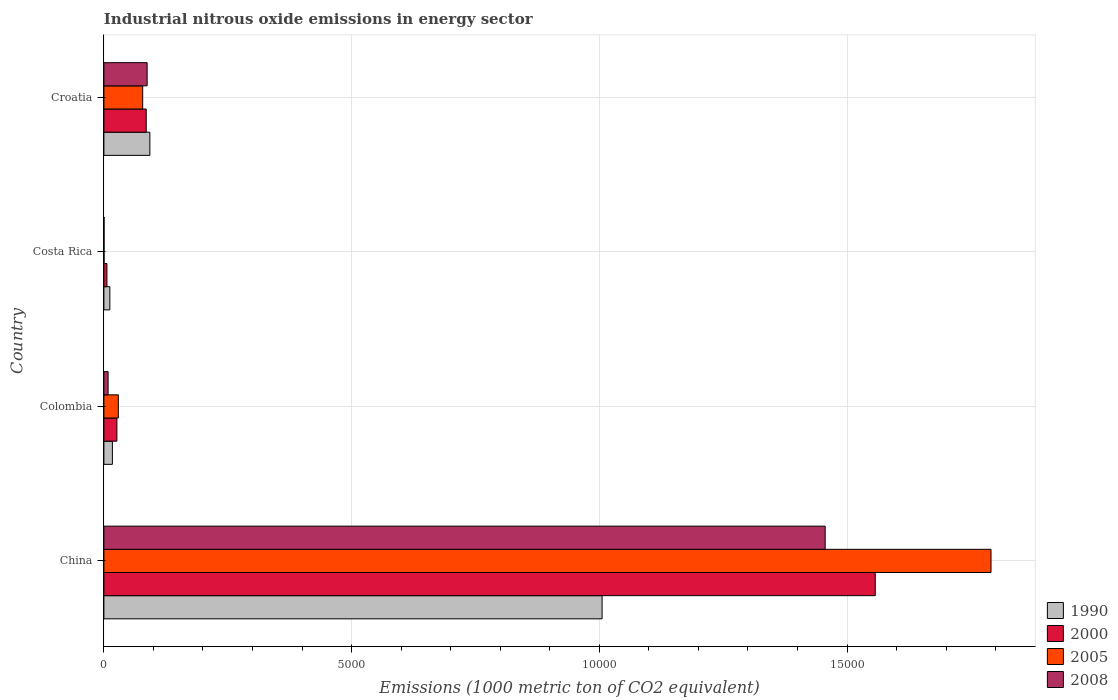How many different coloured bars are there?
Provide a short and direct response. 4. How many bars are there on the 4th tick from the bottom?
Your answer should be very brief. 4. What is the label of the 3rd group of bars from the top?
Your response must be concise. Colombia. What is the amount of industrial nitrous oxide emitted in 1990 in Costa Rica?
Provide a succinct answer. 120. Across all countries, what is the maximum amount of industrial nitrous oxide emitted in 2000?
Keep it short and to the point. 1.56e+04. Across all countries, what is the minimum amount of industrial nitrous oxide emitted in 2008?
Your response must be concise. 3.1. What is the total amount of industrial nitrous oxide emitted in 2008 in the graph?
Make the answer very short. 1.55e+04. What is the difference between the amount of industrial nitrous oxide emitted in 2005 in China and that in Colombia?
Offer a terse response. 1.76e+04. What is the difference between the amount of industrial nitrous oxide emitted in 2005 in Colombia and the amount of industrial nitrous oxide emitted in 1990 in China?
Provide a short and direct response. -9764.8. What is the average amount of industrial nitrous oxide emitted in 1990 per country?
Ensure brevity in your answer.  2818.85. What is the difference between the amount of industrial nitrous oxide emitted in 2008 and amount of industrial nitrous oxide emitted in 2005 in China?
Your response must be concise. -3347.5. What is the ratio of the amount of industrial nitrous oxide emitted in 1990 in China to that in Croatia?
Ensure brevity in your answer.  10.84. Is the amount of industrial nitrous oxide emitted in 2005 in Colombia less than that in Croatia?
Keep it short and to the point. Yes. What is the difference between the highest and the second highest amount of industrial nitrous oxide emitted in 1990?
Offer a terse response. 9128.4. What is the difference between the highest and the lowest amount of industrial nitrous oxide emitted in 2000?
Keep it short and to the point. 1.55e+04. In how many countries, is the amount of industrial nitrous oxide emitted in 1990 greater than the average amount of industrial nitrous oxide emitted in 1990 taken over all countries?
Your answer should be very brief. 1. Is the sum of the amount of industrial nitrous oxide emitted in 2005 in Colombia and Croatia greater than the maximum amount of industrial nitrous oxide emitted in 2000 across all countries?
Your answer should be compact. No. Is it the case that in every country, the sum of the amount of industrial nitrous oxide emitted in 2005 and amount of industrial nitrous oxide emitted in 1990 is greater than the sum of amount of industrial nitrous oxide emitted in 2000 and amount of industrial nitrous oxide emitted in 2008?
Your answer should be very brief. No. What does the 4th bar from the top in Colombia represents?
Your answer should be compact. 1990. What does the 4th bar from the bottom in Croatia represents?
Your response must be concise. 2008. How many bars are there?
Keep it short and to the point. 16. Are all the bars in the graph horizontal?
Make the answer very short. Yes. How many countries are there in the graph?
Your response must be concise. 4. What is the difference between two consecutive major ticks on the X-axis?
Ensure brevity in your answer.  5000. Are the values on the major ticks of X-axis written in scientific E-notation?
Provide a succinct answer. No. Does the graph contain grids?
Make the answer very short. Yes. Where does the legend appear in the graph?
Keep it short and to the point. Bottom right. How many legend labels are there?
Keep it short and to the point. 4. How are the legend labels stacked?
Offer a terse response. Vertical. What is the title of the graph?
Your answer should be very brief. Industrial nitrous oxide emissions in energy sector. Does "1970" appear as one of the legend labels in the graph?
Provide a short and direct response. No. What is the label or title of the X-axis?
Your answer should be very brief. Emissions (1000 metric ton of CO2 equivalent). What is the label or title of the Y-axis?
Keep it short and to the point. Country. What is the Emissions (1000 metric ton of CO2 equivalent) in 1990 in China?
Your answer should be compact. 1.01e+04. What is the Emissions (1000 metric ton of CO2 equivalent) in 2000 in China?
Provide a short and direct response. 1.56e+04. What is the Emissions (1000 metric ton of CO2 equivalent) of 2005 in China?
Make the answer very short. 1.79e+04. What is the Emissions (1000 metric ton of CO2 equivalent) of 2008 in China?
Provide a short and direct response. 1.46e+04. What is the Emissions (1000 metric ton of CO2 equivalent) in 1990 in Colombia?
Provide a short and direct response. 171.6. What is the Emissions (1000 metric ton of CO2 equivalent) in 2000 in Colombia?
Provide a short and direct response. 262.3. What is the Emissions (1000 metric ton of CO2 equivalent) of 2005 in Colombia?
Your response must be concise. 291.3. What is the Emissions (1000 metric ton of CO2 equivalent) in 2008 in Colombia?
Your answer should be very brief. 84.7. What is the Emissions (1000 metric ton of CO2 equivalent) in 1990 in Costa Rica?
Provide a succinct answer. 120. What is the Emissions (1000 metric ton of CO2 equivalent) of 2000 in Costa Rica?
Your response must be concise. 61.4. What is the Emissions (1000 metric ton of CO2 equivalent) of 2008 in Costa Rica?
Offer a terse response. 3.1. What is the Emissions (1000 metric ton of CO2 equivalent) in 1990 in Croatia?
Your response must be concise. 927.7. What is the Emissions (1000 metric ton of CO2 equivalent) of 2000 in Croatia?
Your answer should be very brief. 854.3. What is the Emissions (1000 metric ton of CO2 equivalent) in 2005 in Croatia?
Your response must be concise. 783.2. What is the Emissions (1000 metric ton of CO2 equivalent) of 2008 in Croatia?
Keep it short and to the point. 873. Across all countries, what is the maximum Emissions (1000 metric ton of CO2 equivalent) of 1990?
Ensure brevity in your answer.  1.01e+04. Across all countries, what is the maximum Emissions (1000 metric ton of CO2 equivalent) in 2000?
Your answer should be compact. 1.56e+04. Across all countries, what is the maximum Emissions (1000 metric ton of CO2 equivalent) of 2005?
Offer a very short reply. 1.79e+04. Across all countries, what is the maximum Emissions (1000 metric ton of CO2 equivalent) of 2008?
Offer a very short reply. 1.46e+04. Across all countries, what is the minimum Emissions (1000 metric ton of CO2 equivalent) of 1990?
Offer a very short reply. 120. Across all countries, what is the minimum Emissions (1000 metric ton of CO2 equivalent) in 2000?
Your answer should be very brief. 61.4. What is the total Emissions (1000 metric ton of CO2 equivalent) in 1990 in the graph?
Provide a short and direct response. 1.13e+04. What is the total Emissions (1000 metric ton of CO2 equivalent) in 2000 in the graph?
Keep it short and to the point. 1.67e+04. What is the total Emissions (1000 metric ton of CO2 equivalent) of 2005 in the graph?
Provide a short and direct response. 1.90e+04. What is the total Emissions (1000 metric ton of CO2 equivalent) of 2008 in the graph?
Offer a terse response. 1.55e+04. What is the difference between the Emissions (1000 metric ton of CO2 equivalent) in 1990 in China and that in Colombia?
Your answer should be very brief. 9884.5. What is the difference between the Emissions (1000 metric ton of CO2 equivalent) of 2000 in China and that in Colombia?
Your answer should be very brief. 1.53e+04. What is the difference between the Emissions (1000 metric ton of CO2 equivalent) in 2005 in China and that in Colombia?
Your answer should be compact. 1.76e+04. What is the difference between the Emissions (1000 metric ton of CO2 equivalent) of 2008 in China and that in Colombia?
Provide a succinct answer. 1.45e+04. What is the difference between the Emissions (1000 metric ton of CO2 equivalent) in 1990 in China and that in Costa Rica?
Provide a short and direct response. 9936.1. What is the difference between the Emissions (1000 metric ton of CO2 equivalent) of 2000 in China and that in Costa Rica?
Make the answer very short. 1.55e+04. What is the difference between the Emissions (1000 metric ton of CO2 equivalent) of 2005 in China and that in Costa Rica?
Your response must be concise. 1.79e+04. What is the difference between the Emissions (1000 metric ton of CO2 equivalent) in 2008 in China and that in Costa Rica?
Keep it short and to the point. 1.46e+04. What is the difference between the Emissions (1000 metric ton of CO2 equivalent) in 1990 in China and that in Croatia?
Your answer should be compact. 9128.4. What is the difference between the Emissions (1000 metric ton of CO2 equivalent) in 2000 in China and that in Croatia?
Your answer should be very brief. 1.47e+04. What is the difference between the Emissions (1000 metric ton of CO2 equivalent) in 2005 in China and that in Croatia?
Provide a succinct answer. 1.71e+04. What is the difference between the Emissions (1000 metric ton of CO2 equivalent) in 2008 in China and that in Croatia?
Your response must be concise. 1.37e+04. What is the difference between the Emissions (1000 metric ton of CO2 equivalent) in 1990 in Colombia and that in Costa Rica?
Provide a succinct answer. 51.6. What is the difference between the Emissions (1000 metric ton of CO2 equivalent) of 2000 in Colombia and that in Costa Rica?
Your response must be concise. 200.9. What is the difference between the Emissions (1000 metric ton of CO2 equivalent) in 2005 in Colombia and that in Costa Rica?
Your answer should be compact. 288.2. What is the difference between the Emissions (1000 metric ton of CO2 equivalent) in 2008 in Colombia and that in Costa Rica?
Keep it short and to the point. 81.6. What is the difference between the Emissions (1000 metric ton of CO2 equivalent) in 1990 in Colombia and that in Croatia?
Ensure brevity in your answer.  -756.1. What is the difference between the Emissions (1000 metric ton of CO2 equivalent) of 2000 in Colombia and that in Croatia?
Your answer should be very brief. -592. What is the difference between the Emissions (1000 metric ton of CO2 equivalent) in 2005 in Colombia and that in Croatia?
Your answer should be very brief. -491.9. What is the difference between the Emissions (1000 metric ton of CO2 equivalent) in 2008 in Colombia and that in Croatia?
Ensure brevity in your answer.  -788.3. What is the difference between the Emissions (1000 metric ton of CO2 equivalent) of 1990 in Costa Rica and that in Croatia?
Your answer should be compact. -807.7. What is the difference between the Emissions (1000 metric ton of CO2 equivalent) in 2000 in Costa Rica and that in Croatia?
Your response must be concise. -792.9. What is the difference between the Emissions (1000 metric ton of CO2 equivalent) in 2005 in Costa Rica and that in Croatia?
Ensure brevity in your answer.  -780.1. What is the difference between the Emissions (1000 metric ton of CO2 equivalent) in 2008 in Costa Rica and that in Croatia?
Your answer should be very brief. -869.9. What is the difference between the Emissions (1000 metric ton of CO2 equivalent) in 1990 in China and the Emissions (1000 metric ton of CO2 equivalent) in 2000 in Colombia?
Give a very brief answer. 9793.8. What is the difference between the Emissions (1000 metric ton of CO2 equivalent) of 1990 in China and the Emissions (1000 metric ton of CO2 equivalent) of 2005 in Colombia?
Provide a short and direct response. 9764.8. What is the difference between the Emissions (1000 metric ton of CO2 equivalent) in 1990 in China and the Emissions (1000 metric ton of CO2 equivalent) in 2008 in Colombia?
Provide a succinct answer. 9971.4. What is the difference between the Emissions (1000 metric ton of CO2 equivalent) of 2000 in China and the Emissions (1000 metric ton of CO2 equivalent) of 2005 in Colombia?
Offer a very short reply. 1.53e+04. What is the difference between the Emissions (1000 metric ton of CO2 equivalent) of 2000 in China and the Emissions (1000 metric ton of CO2 equivalent) of 2008 in Colombia?
Provide a short and direct response. 1.55e+04. What is the difference between the Emissions (1000 metric ton of CO2 equivalent) in 2005 in China and the Emissions (1000 metric ton of CO2 equivalent) in 2008 in Colombia?
Provide a succinct answer. 1.78e+04. What is the difference between the Emissions (1000 metric ton of CO2 equivalent) of 1990 in China and the Emissions (1000 metric ton of CO2 equivalent) of 2000 in Costa Rica?
Give a very brief answer. 9994.7. What is the difference between the Emissions (1000 metric ton of CO2 equivalent) in 1990 in China and the Emissions (1000 metric ton of CO2 equivalent) in 2005 in Costa Rica?
Make the answer very short. 1.01e+04. What is the difference between the Emissions (1000 metric ton of CO2 equivalent) of 1990 in China and the Emissions (1000 metric ton of CO2 equivalent) of 2008 in Costa Rica?
Ensure brevity in your answer.  1.01e+04. What is the difference between the Emissions (1000 metric ton of CO2 equivalent) of 2000 in China and the Emissions (1000 metric ton of CO2 equivalent) of 2005 in Costa Rica?
Your answer should be compact. 1.56e+04. What is the difference between the Emissions (1000 metric ton of CO2 equivalent) in 2000 in China and the Emissions (1000 metric ton of CO2 equivalent) in 2008 in Costa Rica?
Offer a terse response. 1.56e+04. What is the difference between the Emissions (1000 metric ton of CO2 equivalent) in 2005 in China and the Emissions (1000 metric ton of CO2 equivalent) in 2008 in Costa Rica?
Offer a terse response. 1.79e+04. What is the difference between the Emissions (1000 metric ton of CO2 equivalent) in 1990 in China and the Emissions (1000 metric ton of CO2 equivalent) in 2000 in Croatia?
Provide a short and direct response. 9201.8. What is the difference between the Emissions (1000 metric ton of CO2 equivalent) of 1990 in China and the Emissions (1000 metric ton of CO2 equivalent) of 2005 in Croatia?
Offer a terse response. 9272.9. What is the difference between the Emissions (1000 metric ton of CO2 equivalent) of 1990 in China and the Emissions (1000 metric ton of CO2 equivalent) of 2008 in Croatia?
Provide a short and direct response. 9183.1. What is the difference between the Emissions (1000 metric ton of CO2 equivalent) in 2000 in China and the Emissions (1000 metric ton of CO2 equivalent) in 2005 in Croatia?
Give a very brief answer. 1.48e+04. What is the difference between the Emissions (1000 metric ton of CO2 equivalent) of 2000 in China and the Emissions (1000 metric ton of CO2 equivalent) of 2008 in Croatia?
Make the answer very short. 1.47e+04. What is the difference between the Emissions (1000 metric ton of CO2 equivalent) in 2005 in China and the Emissions (1000 metric ton of CO2 equivalent) in 2008 in Croatia?
Your answer should be very brief. 1.70e+04. What is the difference between the Emissions (1000 metric ton of CO2 equivalent) of 1990 in Colombia and the Emissions (1000 metric ton of CO2 equivalent) of 2000 in Costa Rica?
Offer a very short reply. 110.2. What is the difference between the Emissions (1000 metric ton of CO2 equivalent) of 1990 in Colombia and the Emissions (1000 metric ton of CO2 equivalent) of 2005 in Costa Rica?
Offer a terse response. 168.5. What is the difference between the Emissions (1000 metric ton of CO2 equivalent) of 1990 in Colombia and the Emissions (1000 metric ton of CO2 equivalent) of 2008 in Costa Rica?
Offer a very short reply. 168.5. What is the difference between the Emissions (1000 metric ton of CO2 equivalent) of 2000 in Colombia and the Emissions (1000 metric ton of CO2 equivalent) of 2005 in Costa Rica?
Provide a short and direct response. 259.2. What is the difference between the Emissions (1000 metric ton of CO2 equivalent) of 2000 in Colombia and the Emissions (1000 metric ton of CO2 equivalent) of 2008 in Costa Rica?
Make the answer very short. 259.2. What is the difference between the Emissions (1000 metric ton of CO2 equivalent) of 2005 in Colombia and the Emissions (1000 metric ton of CO2 equivalent) of 2008 in Costa Rica?
Provide a succinct answer. 288.2. What is the difference between the Emissions (1000 metric ton of CO2 equivalent) of 1990 in Colombia and the Emissions (1000 metric ton of CO2 equivalent) of 2000 in Croatia?
Provide a succinct answer. -682.7. What is the difference between the Emissions (1000 metric ton of CO2 equivalent) of 1990 in Colombia and the Emissions (1000 metric ton of CO2 equivalent) of 2005 in Croatia?
Ensure brevity in your answer.  -611.6. What is the difference between the Emissions (1000 metric ton of CO2 equivalent) in 1990 in Colombia and the Emissions (1000 metric ton of CO2 equivalent) in 2008 in Croatia?
Offer a terse response. -701.4. What is the difference between the Emissions (1000 metric ton of CO2 equivalent) of 2000 in Colombia and the Emissions (1000 metric ton of CO2 equivalent) of 2005 in Croatia?
Give a very brief answer. -520.9. What is the difference between the Emissions (1000 metric ton of CO2 equivalent) of 2000 in Colombia and the Emissions (1000 metric ton of CO2 equivalent) of 2008 in Croatia?
Provide a short and direct response. -610.7. What is the difference between the Emissions (1000 metric ton of CO2 equivalent) of 2005 in Colombia and the Emissions (1000 metric ton of CO2 equivalent) of 2008 in Croatia?
Make the answer very short. -581.7. What is the difference between the Emissions (1000 metric ton of CO2 equivalent) of 1990 in Costa Rica and the Emissions (1000 metric ton of CO2 equivalent) of 2000 in Croatia?
Give a very brief answer. -734.3. What is the difference between the Emissions (1000 metric ton of CO2 equivalent) in 1990 in Costa Rica and the Emissions (1000 metric ton of CO2 equivalent) in 2005 in Croatia?
Your answer should be compact. -663.2. What is the difference between the Emissions (1000 metric ton of CO2 equivalent) of 1990 in Costa Rica and the Emissions (1000 metric ton of CO2 equivalent) of 2008 in Croatia?
Your answer should be very brief. -753. What is the difference between the Emissions (1000 metric ton of CO2 equivalent) of 2000 in Costa Rica and the Emissions (1000 metric ton of CO2 equivalent) of 2005 in Croatia?
Provide a succinct answer. -721.8. What is the difference between the Emissions (1000 metric ton of CO2 equivalent) in 2000 in Costa Rica and the Emissions (1000 metric ton of CO2 equivalent) in 2008 in Croatia?
Provide a succinct answer. -811.6. What is the difference between the Emissions (1000 metric ton of CO2 equivalent) in 2005 in Costa Rica and the Emissions (1000 metric ton of CO2 equivalent) in 2008 in Croatia?
Offer a very short reply. -869.9. What is the average Emissions (1000 metric ton of CO2 equivalent) in 1990 per country?
Ensure brevity in your answer.  2818.85. What is the average Emissions (1000 metric ton of CO2 equivalent) in 2000 per country?
Provide a short and direct response. 4186.93. What is the average Emissions (1000 metric ton of CO2 equivalent) in 2005 per country?
Give a very brief answer. 4746. What is the average Emissions (1000 metric ton of CO2 equivalent) of 2008 per country?
Ensure brevity in your answer.  3879.93. What is the difference between the Emissions (1000 metric ton of CO2 equivalent) of 1990 and Emissions (1000 metric ton of CO2 equivalent) of 2000 in China?
Keep it short and to the point. -5513.6. What is the difference between the Emissions (1000 metric ton of CO2 equivalent) in 1990 and Emissions (1000 metric ton of CO2 equivalent) in 2005 in China?
Your answer should be compact. -7850.3. What is the difference between the Emissions (1000 metric ton of CO2 equivalent) of 1990 and Emissions (1000 metric ton of CO2 equivalent) of 2008 in China?
Your answer should be compact. -4502.8. What is the difference between the Emissions (1000 metric ton of CO2 equivalent) in 2000 and Emissions (1000 metric ton of CO2 equivalent) in 2005 in China?
Your response must be concise. -2336.7. What is the difference between the Emissions (1000 metric ton of CO2 equivalent) in 2000 and Emissions (1000 metric ton of CO2 equivalent) in 2008 in China?
Provide a short and direct response. 1010.8. What is the difference between the Emissions (1000 metric ton of CO2 equivalent) in 2005 and Emissions (1000 metric ton of CO2 equivalent) in 2008 in China?
Offer a very short reply. 3347.5. What is the difference between the Emissions (1000 metric ton of CO2 equivalent) in 1990 and Emissions (1000 metric ton of CO2 equivalent) in 2000 in Colombia?
Your response must be concise. -90.7. What is the difference between the Emissions (1000 metric ton of CO2 equivalent) of 1990 and Emissions (1000 metric ton of CO2 equivalent) of 2005 in Colombia?
Your response must be concise. -119.7. What is the difference between the Emissions (1000 metric ton of CO2 equivalent) in 1990 and Emissions (1000 metric ton of CO2 equivalent) in 2008 in Colombia?
Your answer should be very brief. 86.9. What is the difference between the Emissions (1000 metric ton of CO2 equivalent) of 2000 and Emissions (1000 metric ton of CO2 equivalent) of 2008 in Colombia?
Provide a short and direct response. 177.6. What is the difference between the Emissions (1000 metric ton of CO2 equivalent) in 2005 and Emissions (1000 metric ton of CO2 equivalent) in 2008 in Colombia?
Provide a short and direct response. 206.6. What is the difference between the Emissions (1000 metric ton of CO2 equivalent) in 1990 and Emissions (1000 metric ton of CO2 equivalent) in 2000 in Costa Rica?
Ensure brevity in your answer.  58.6. What is the difference between the Emissions (1000 metric ton of CO2 equivalent) of 1990 and Emissions (1000 metric ton of CO2 equivalent) of 2005 in Costa Rica?
Provide a short and direct response. 116.9. What is the difference between the Emissions (1000 metric ton of CO2 equivalent) in 1990 and Emissions (1000 metric ton of CO2 equivalent) in 2008 in Costa Rica?
Provide a succinct answer. 116.9. What is the difference between the Emissions (1000 metric ton of CO2 equivalent) in 2000 and Emissions (1000 metric ton of CO2 equivalent) in 2005 in Costa Rica?
Ensure brevity in your answer.  58.3. What is the difference between the Emissions (1000 metric ton of CO2 equivalent) in 2000 and Emissions (1000 metric ton of CO2 equivalent) in 2008 in Costa Rica?
Make the answer very short. 58.3. What is the difference between the Emissions (1000 metric ton of CO2 equivalent) of 2005 and Emissions (1000 metric ton of CO2 equivalent) of 2008 in Costa Rica?
Your response must be concise. 0. What is the difference between the Emissions (1000 metric ton of CO2 equivalent) in 1990 and Emissions (1000 metric ton of CO2 equivalent) in 2000 in Croatia?
Keep it short and to the point. 73.4. What is the difference between the Emissions (1000 metric ton of CO2 equivalent) of 1990 and Emissions (1000 metric ton of CO2 equivalent) of 2005 in Croatia?
Your answer should be very brief. 144.5. What is the difference between the Emissions (1000 metric ton of CO2 equivalent) of 1990 and Emissions (1000 metric ton of CO2 equivalent) of 2008 in Croatia?
Your answer should be compact. 54.7. What is the difference between the Emissions (1000 metric ton of CO2 equivalent) in 2000 and Emissions (1000 metric ton of CO2 equivalent) in 2005 in Croatia?
Your response must be concise. 71.1. What is the difference between the Emissions (1000 metric ton of CO2 equivalent) of 2000 and Emissions (1000 metric ton of CO2 equivalent) of 2008 in Croatia?
Your answer should be very brief. -18.7. What is the difference between the Emissions (1000 metric ton of CO2 equivalent) of 2005 and Emissions (1000 metric ton of CO2 equivalent) of 2008 in Croatia?
Provide a short and direct response. -89.8. What is the ratio of the Emissions (1000 metric ton of CO2 equivalent) in 1990 in China to that in Colombia?
Provide a short and direct response. 58.6. What is the ratio of the Emissions (1000 metric ton of CO2 equivalent) in 2000 in China to that in Colombia?
Your answer should be very brief. 59.36. What is the ratio of the Emissions (1000 metric ton of CO2 equivalent) of 2005 in China to that in Colombia?
Your answer should be very brief. 61.47. What is the ratio of the Emissions (1000 metric ton of CO2 equivalent) of 2008 in China to that in Colombia?
Provide a short and direct response. 171.89. What is the ratio of the Emissions (1000 metric ton of CO2 equivalent) in 1990 in China to that in Costa Rica?
Offer a very short reply. 83.8. What is the ratio of the Emissions (1000 metric ton of CO2 equivalent) of 2000 in China to that in Costa Rica?
Keep it short and to the point. 253.58. What is the ratio of the Emissions (1000 metric ton of CO2 equivalent) of 2005 in China to that in Costa Rica?
Make the answer very short. 5776.26. What is the ratio of the Emissions (1000 metric ton of CO2 equivalent) in 2008 in China to that in Costa Rica?
Provide a short and direct response. 4696.42. What is the ratio of the Emissions (1000 metric ton of CO2 equivalent) in 1990 in China to that in Croatia?
Offer a very short reply. 10.84. What is the ratio of the Emissions (1000 metric ton of CO2 equivalent) of 2000 in China to that in Croatia?
Provide a succinct answer. 18.23. What is the ratio of the Emissions (1000 metric ton of CO2 equivalent) of 2005 in China to that in Croatia?
Your answer should be compact. 22.86. What is the ratio of the Emissions (1000 metric ton of CO2 equivalent) in 2008 in China to that in Croatia?
Ensure brevity in your answer.  16.68. What is the ratio of the Emissions (1000 metric ton of CO2 equivalent) of 1990 in Colombia to that in Costa Rica?
Your response must be concise. 1.43. What is the ratio of the Emissions (1000 metric ton of CO2 equivalent) of 2000 in Colombia to that in Costa Rica?
Offer a very short reply. 4.27. What is the ratio of the Emissions (1000 metric ton of CO2 equivalent) of 2005 in Colombia to that in Costa Rica?
Your answer should be compact. 93.97. What is the ratio of the Emissions (1000 metric ton of CO2 equivalent) in 2008 in Colombia to that in Costa Rica?
Provide a succinct answer. 27.32. What is the ratio of the Emissions (1000 metric ton of CO2 equivalent) of 1990 in Colombia to that in Croatia?
Make the answer very short. 0.18. What is the ratio of the Emissions (1000 metric ton of CO2 equivalent) of 2000 in Colombia to that in Croatia?
Your response must be concise. 0.31. What is the ratio of the Emissions (1000 metric ton of CO2 equivalent) in 2005 in Colombia to that in Croatia?
Your answer should be compact. 0.37. What is the ratio of the Emissions (1000 metric ton of CO2 equivalent) in 2008 in Colombia to that in Croatia?
Provide a succinct answer. 0.1. What is the ratio of the Emissions (1000 metric ton of CO2 equivalent) of 1990 in Costa Rica to that in Croatia?
Your response must be concise. 0.13. What is the ratio of the Emissions (1000 metric ton of CO2 equivalent) of 2000 in Costa Rica to that in Croatia?
Offer a terse response. 0.07. What is the ratio of the Emissions (1000 metric ton of CO2 equivalent) in 2005 in Costa Rica to that in Croatia?
Your response must be concise. 0. What is the ratio of the Emissions (1000 metric ton of CO2 equivalent) of 2008 in Costa Rica to that in Croatia?
Your answer should be very brief. 0. What is the difference between the highest and the second highest Emissions (1000 metric ton of CO2 equivalent) in 1990?
Keep it short and to the point. 9128.4. What is the difference between the highest and the second highest Emissions (1000 metric ton of CO2 equivalent) of 2000?
Offer a very short reply. 1.47e+04. What is the difference between the highest and the second highest Emissions (1000 metric ton of CO2 equivalent) of 2005?
Your answer should be compact. 1.71e+04. What is the difference between the highest and the second highest Emissions (1000 metric ton of CO2 equivalent) of 2008?
Give a very brief answer. 1.37e+04. What is the difference between the highest and the lowest Emissions (1000 metric ton of CO2 equivalent) of 1990?
Ensure brevity in your answer.  9936.1. What is the difference between the highest and the lowest Emissions (1000 metric ton of CO2 equivalent) in 2000?
Give a very brief answer. 1.55e+04. What is the difference between the highest and the lowest Emissions (1000 metric ton of CO2 equivalent) in 2005?
Provide a succinct answer. 1.79e+04. What is the difference between the highest and the lowest Emissions (1000 metric ton of CO2 equivalent) in 2008?
Keep it short and to the point. 1.46e+04. 